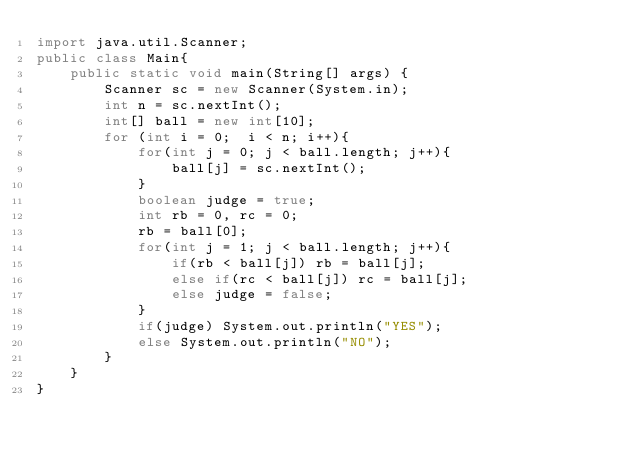Convert code to text. <code><loc_0><loc_0><loc_500><loc_500><_Java_>import java.util.Scanner;
public class Main{
	public static void main(String[] args) {
		Scanner sc = new Scanner(System.in);
		int n = sc.nextInt();
		int[] ball = new int[10];
		for (int i = 0;  i < n; i++){
			for(int j = 0; j < ball.length; j++){
				ball[j] = sc.nextInt();
			}
			boolean judge = true;
			int rb = 0, rc = 0;
			rb = ball[0];
			for(int j = 1; j < ball.length; j++){
				if(rb < ball[j]) rb = ball[j];
				else if(rc < ball[j]) rc = ball[j];
				else judge = false;
			}
			if(judge) System.out.println("YES");
			else System.out.println("NO");
		}
	}
}</code> 